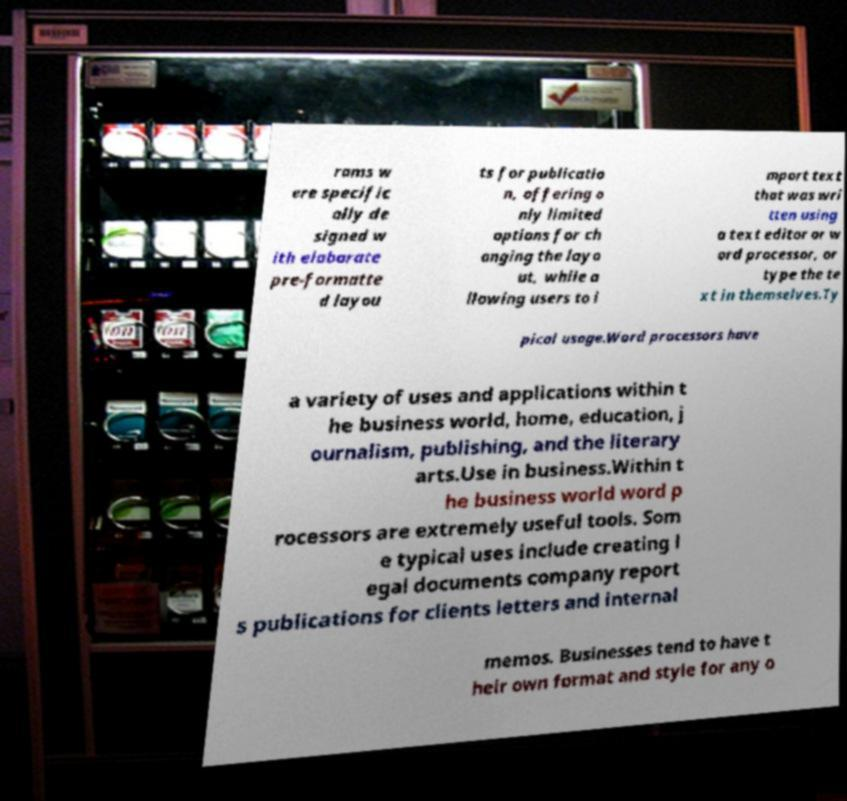There's text embedded in this image that I need extracted. Can you transcribe it verbatim? rams w ere specific ally de signed w ith elaborate pre-formatte d layou ts for publicatio n, offering o nly limited options for ch anging the layo ut, while a llowing users to i mport text that was wri tten using a text editor or w ord processor, or type the te xt in themselves.Ty pical usage.Word processors have a variety of uses and applications within t he business world, home, education, j ournalism, publishing, and the literary arts.Use in business.Within t he business world word p rocessors are extremely useful tools. Som e typical uses include creating l egal documents company report s publications for clients letters and internal memos. Businesses tend to have t heir own format and style for any o 